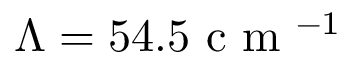Convert formula to latex. <formula><loc_0><loc_0><loc_500><loc_500>\Lambda = 5 4 . 5 c m ^ { - 1 }</formula> 